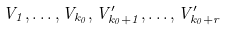Convert formula to latex. <formula><loc_0><loc_0><loc_500><loc_500>V _ { 1 } , \dots , V _ { k _ { 0 } } , V _ { k _ { 0 } + 1 } ^ { \prime } , \dots , V _ { k _ { 0 } + r } ^ { \prime }</formula> 